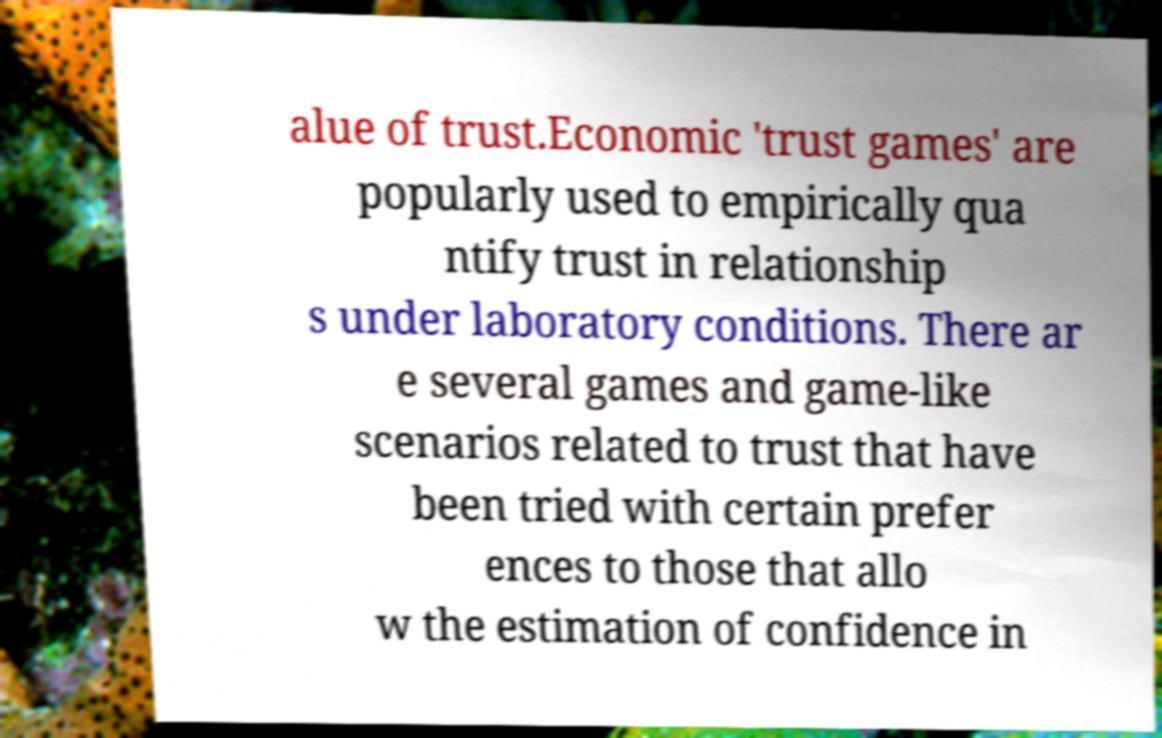Could you extract and type out the text from this image? alue of trust.Economic 'trust games' are popularly used to empirically qua ntify trust in relationship s under laboratory conditions. There ar e several games and game-like scenarios related to trust that have been tried with certain prefer ences to those that allo w the estimation of confidence in 